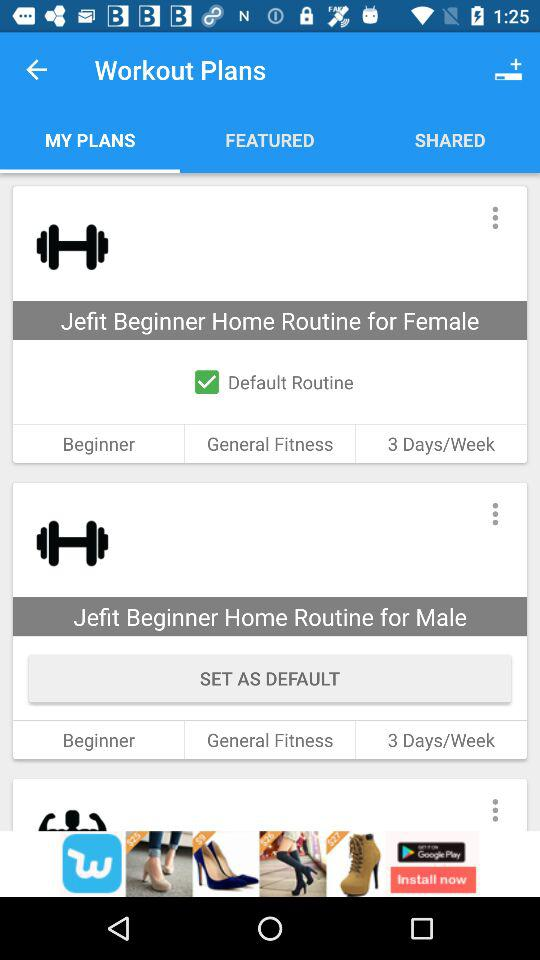For how many days in a week is "Jefit Beginner Home Routine for Female" workout plan? The workout plan is for 3 days in a week. 